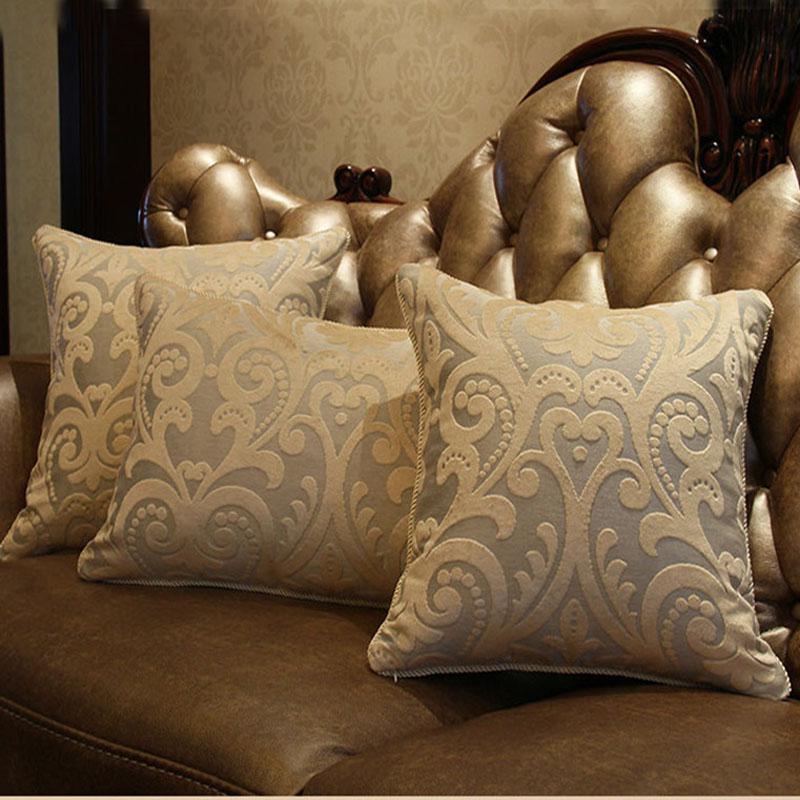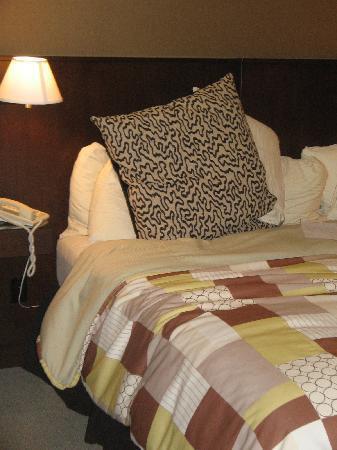The first image is the image on the left, the second image is the image on the right. Examine the images to the left and right. Is the description "An image shows pillows on a bed with a deep brown headboard." accurate? Answer yes or no. Yes. 